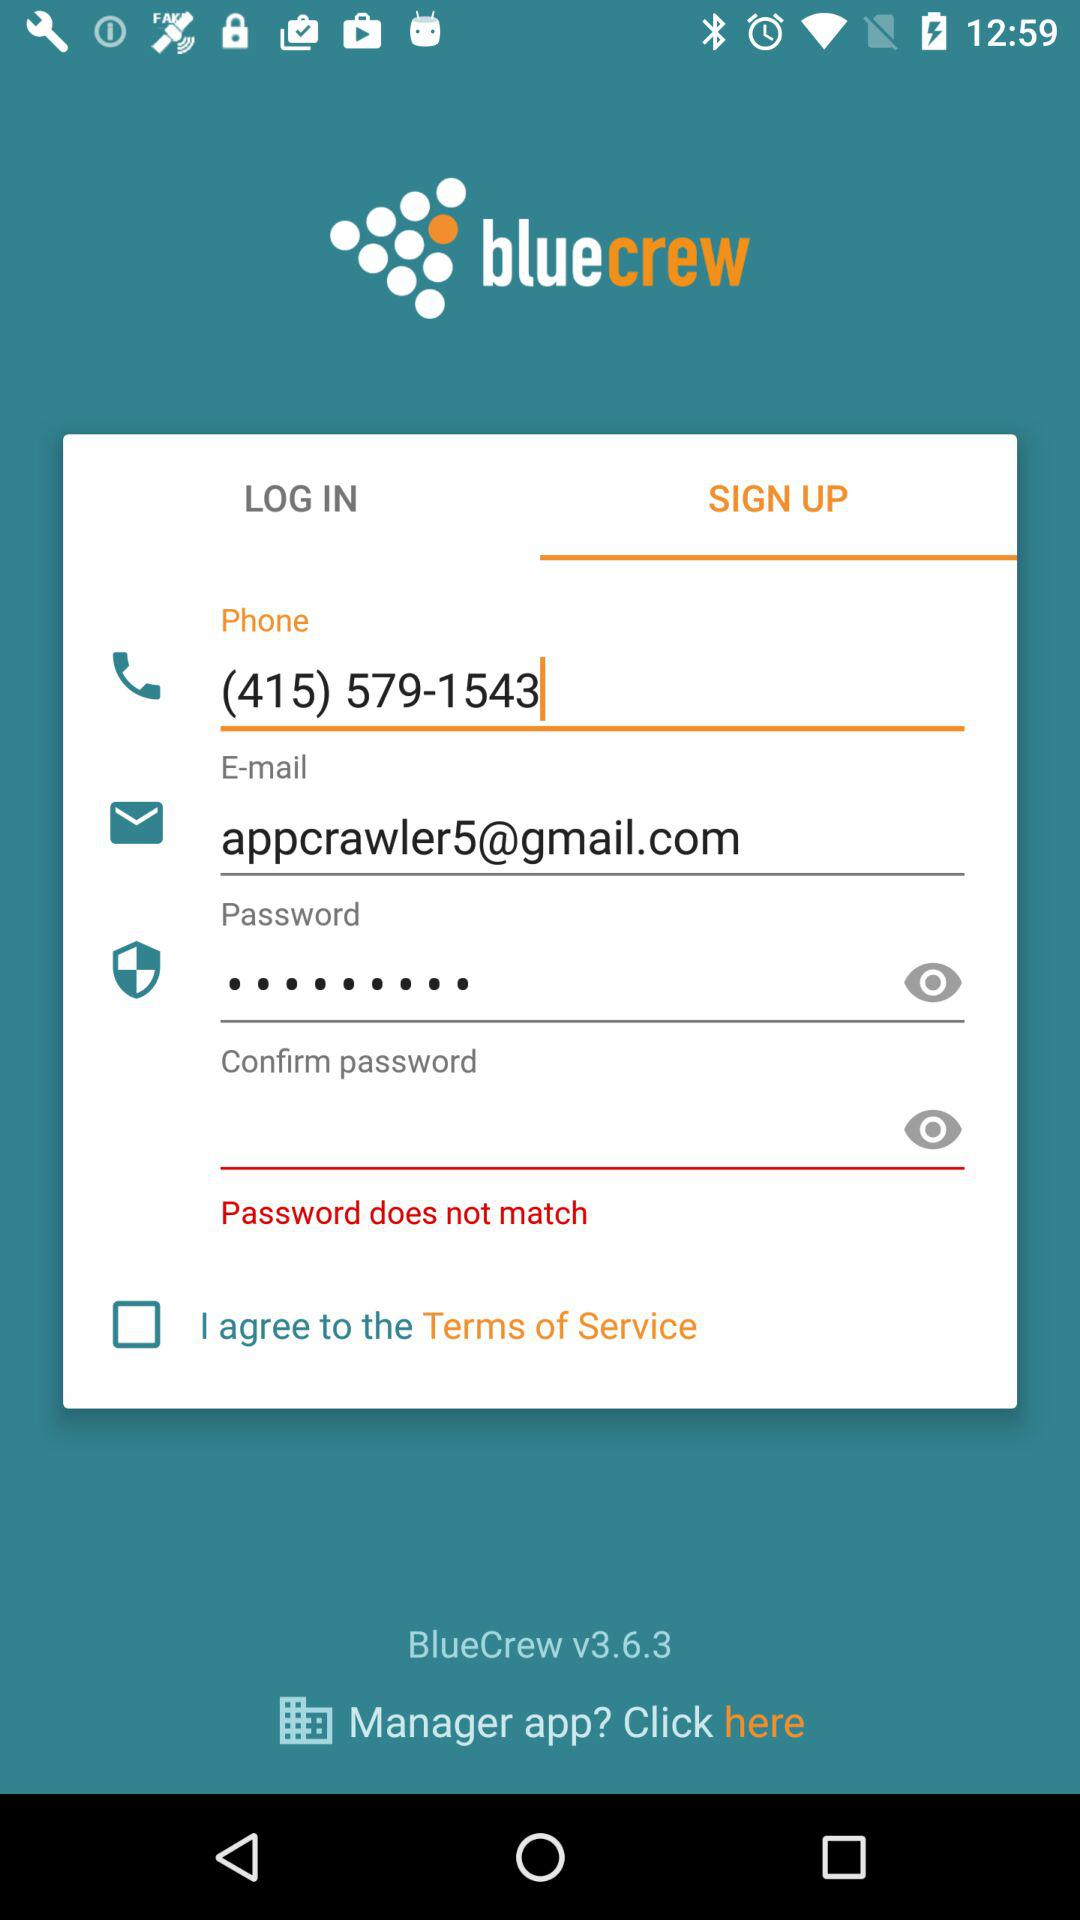What is the phone number? The phone number is (415) 579-1543. 